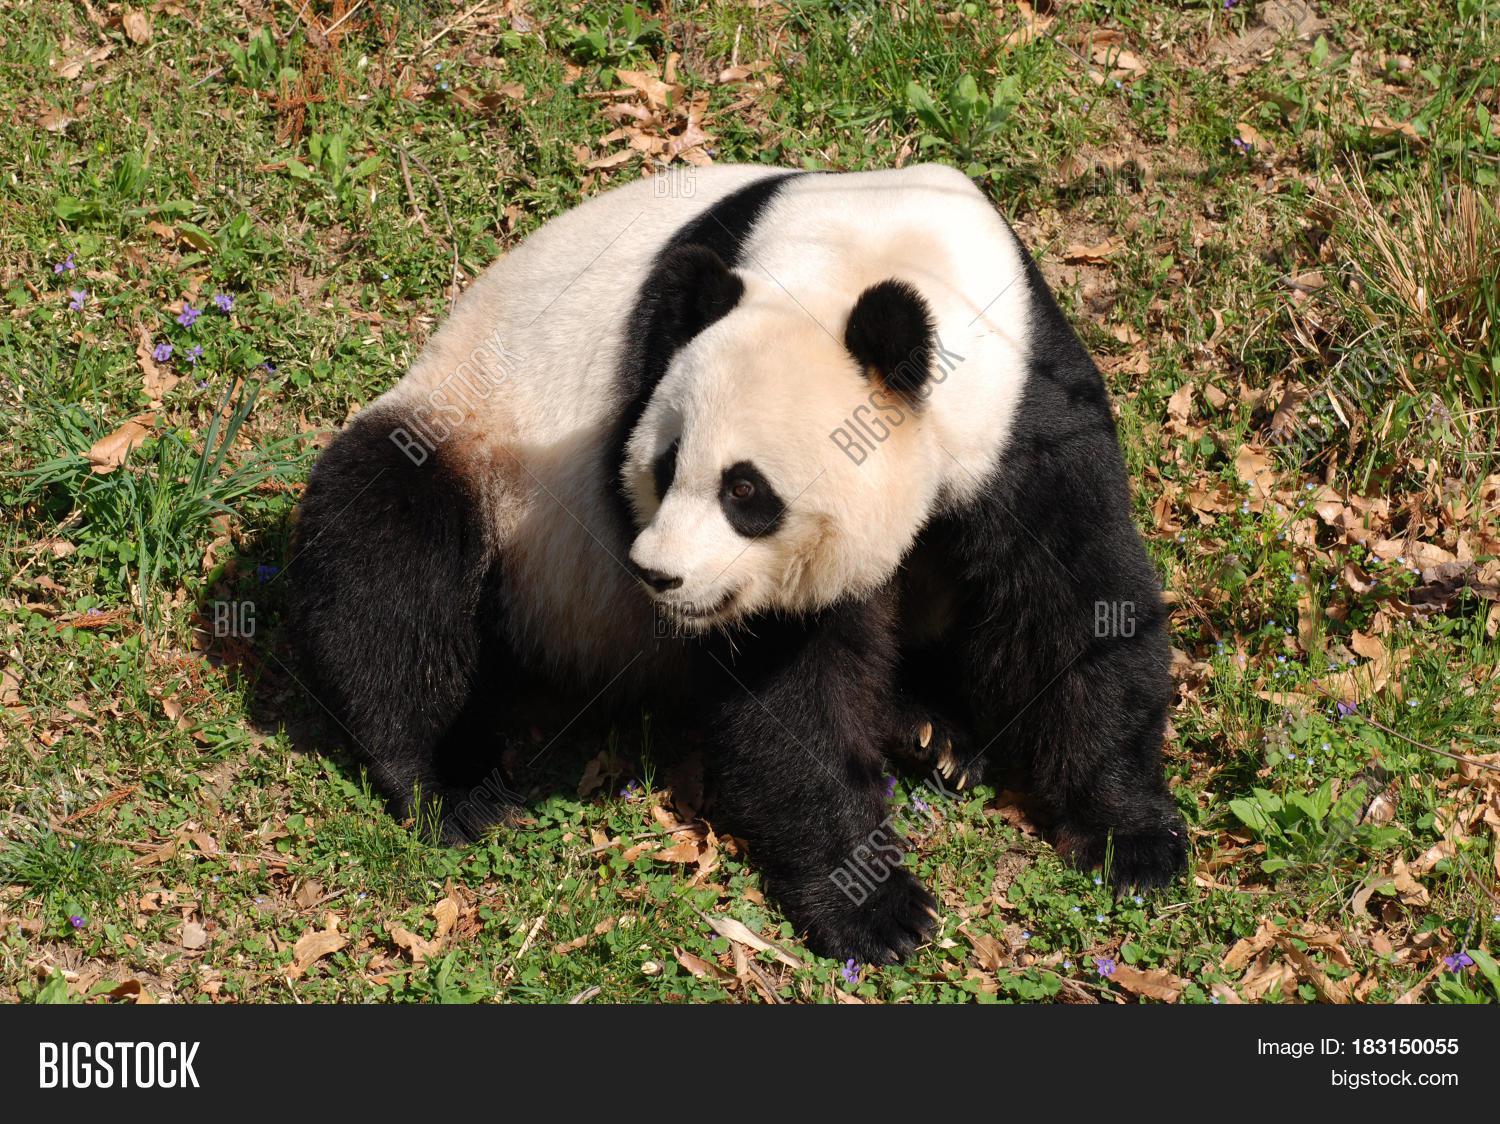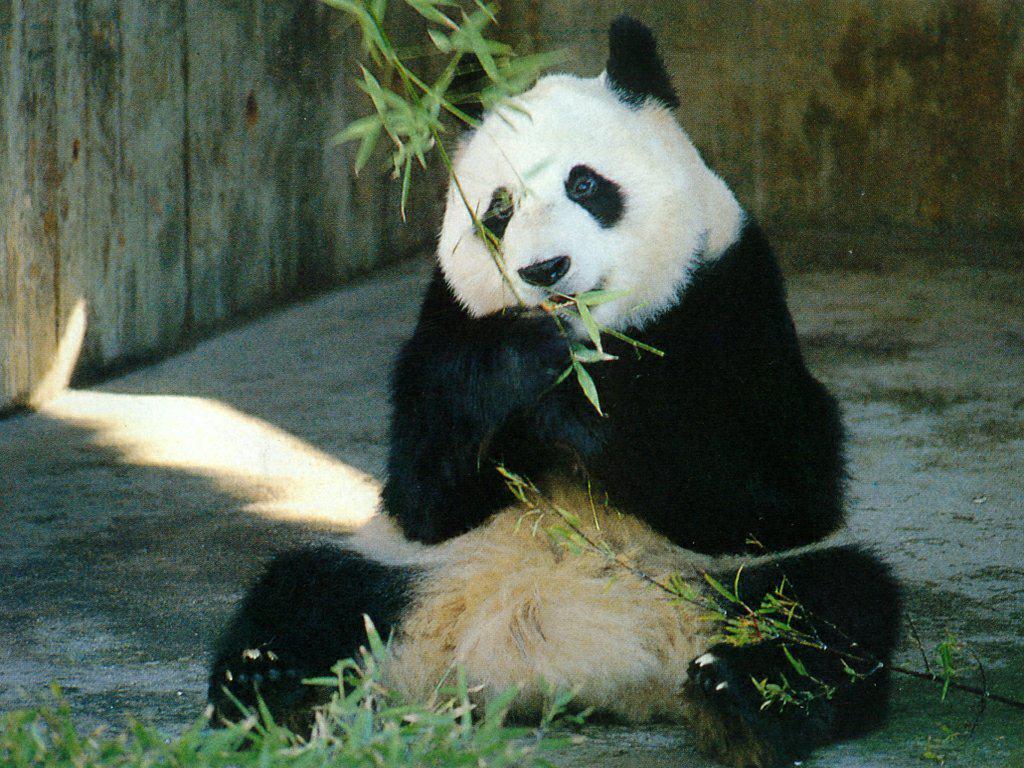The first image is the image on the left, the second image is the image on the right. Considering the images on both sides, is "All pandas are sitting up, and at least one panda is munching on plant material grasped in one paw." valid? Answer yes or no. No. The first image is the image on the left, the second image is the image on the right. Assess this claim about the two images: "The right image contains a panda with bamboo in its mouth.". Correct or not? Answer yes or no. Yes. 